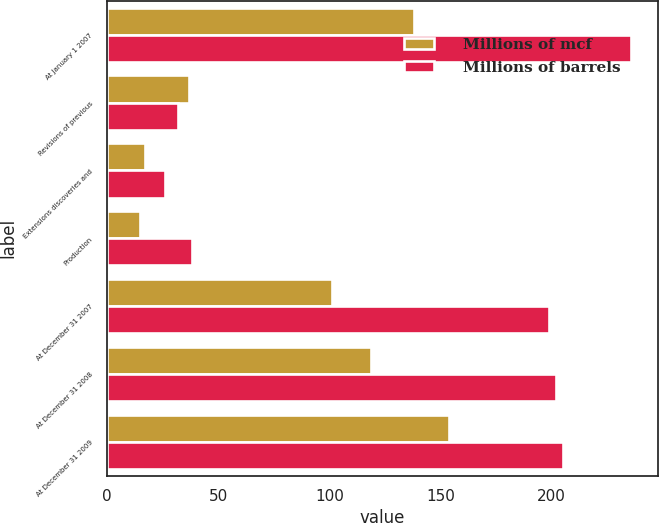<chart> <loc_0><loc_0><loc_500><loc_500><stacked_bar_chart><ecel><fcel>At January 1 2007<fcel>Revisions of previous<fcel>Extensions discoveries and<fcel>Production<fcel>At December 31 2007<fcel>At December 31 2008<fcel>At December 31 2009<nl><fcel>Millions of mcf<fcel>138<fcel>37<fcel>17<fcel>15<fcel>101<fcel>119<fcel>154<nl><fcel>Millions of barrels<fcel>236<fcel>32<fcel>26<fcel>38<fcel>199<fcel>202<fcel>205<nl></chart> 